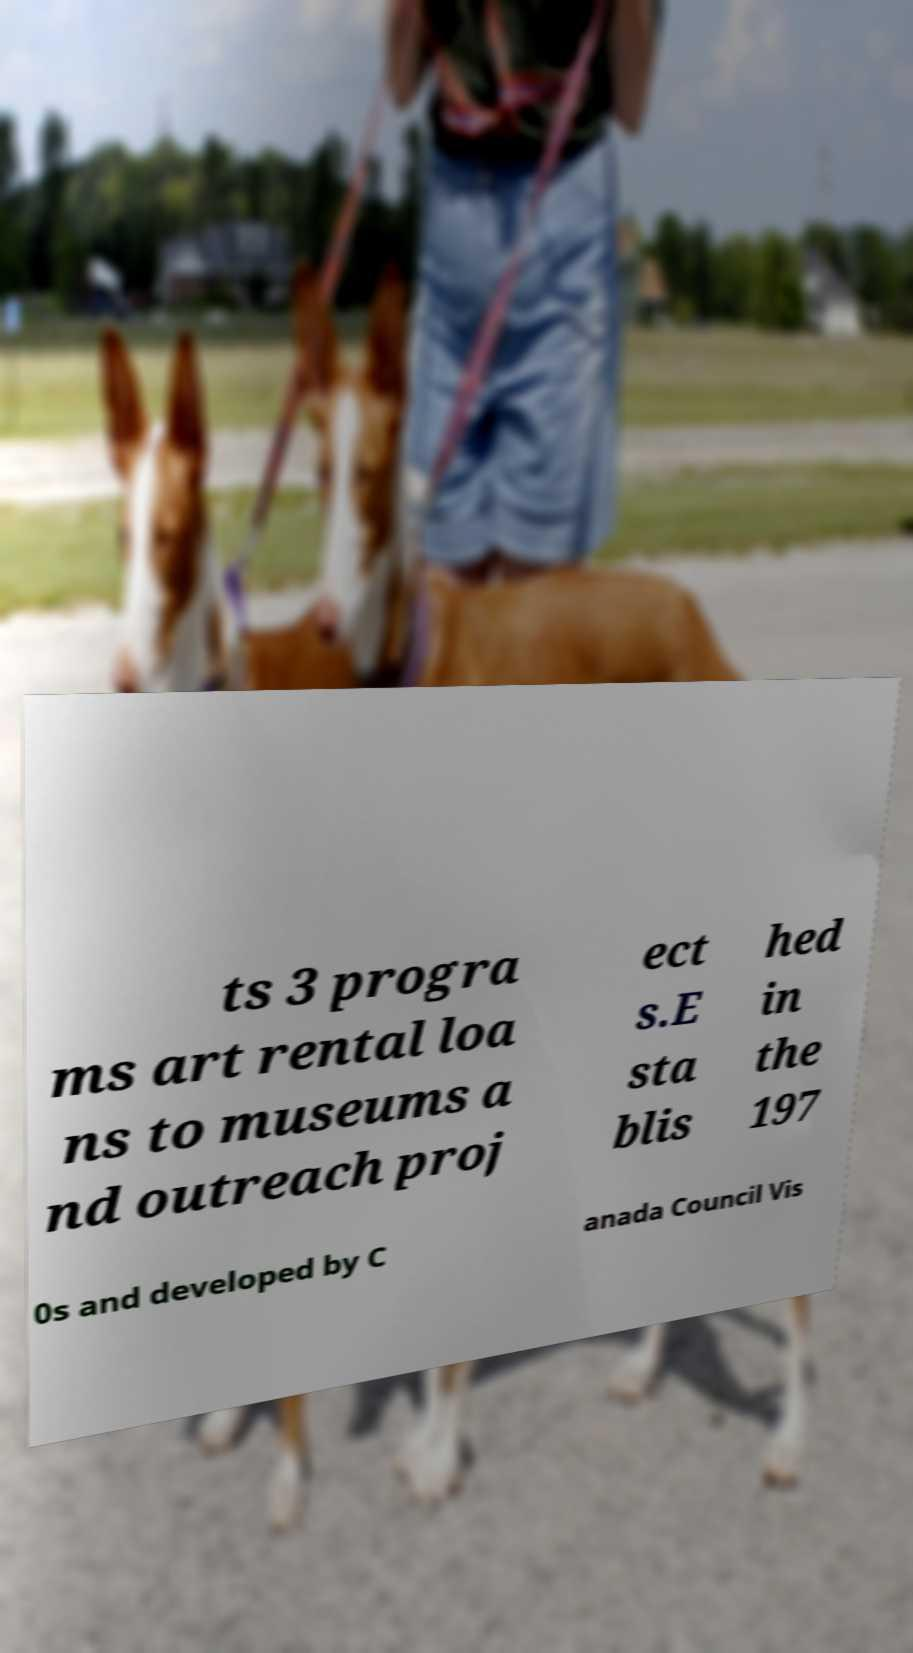Please identify and transcribe the text found in this image. ts 3 progra ms art rental loa ns to museums a nd outreach proj ect s.E sta blis hed in the 197 0s and developed by C anada Council Vis 